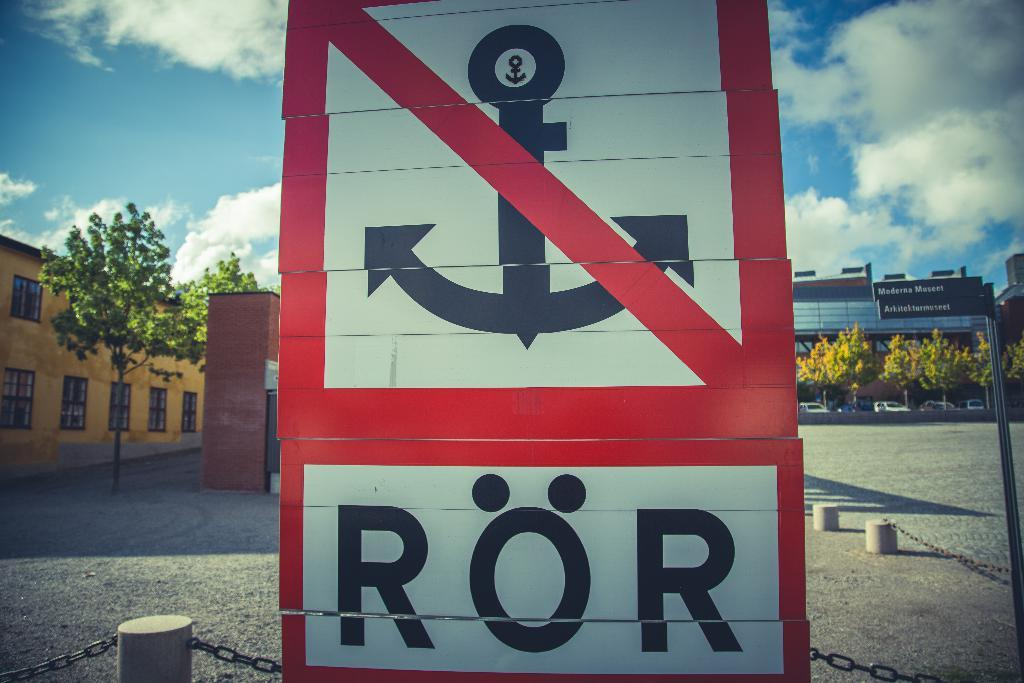What is located in the front of the image? There is a board and chains in the front of the image. What can be seen in the background of the image? Trees, vehicles, buildings, boards, a pole, and a cloudy sky are visible in the background of the image. What type of voice can be heard coming from the bed in the image? There is no bed present in the image, so it is not possible to determine if a voice can be heard. How many snakes are visible in the image? There are no snakes present in the image. 